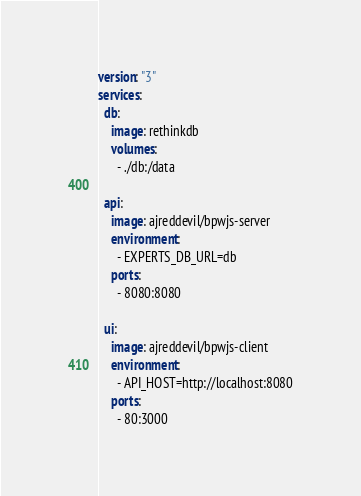<code> <loc_0><loc_0><loc_500><loc_500><_YAML_>version: "3"
services:
  db:
    image: rethinkdb
    volumes:
      - ./db:/data

  api:
    image: ajreddevil/bpwjs-server
    environment:
      - EXPERTS_DB_URL=db
    ports:
      - 8080:8080

  ui:
    image: ajreddevil/bpwjs-client
    environment:
      - API_HOST=http://localhost:8080
    ports:
      - 80:3000</code> 